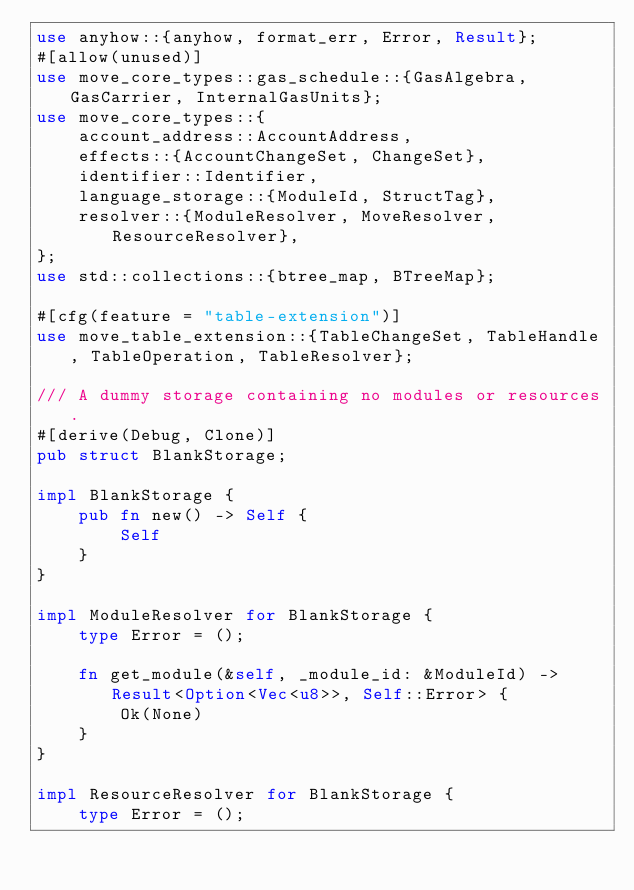Convert code to text. <code><loc_0><loc_0><loc_500><loc_500><_Rust_>use anyhow::{anyhow, format_err, Error, Result};
#[allow(unused)]
use move_core_types::gas_schedule::{GasAlgebra, GasCarrier, InternalGasUnits};
use move_core_types::{
    account_address::AccountAddress,
    effects::{AccountChangeSet, ChangeSet},
    identifier::Identifier,
    language_storage::{ModuleId, StructTag},
    resolver::{ModuleResolver, MoveResolver, ResourceResolver},
};
use std::collections::{btree_map, BTreeMap};

#[cfg(feature = "table-extension")]
use move_table_extension::{TableChangeSet, TableHandle, TableOperation, TableResolver};

/// A dummy storage containing no modules or resources.
#[derive(Debug, Clone)]
pub struct BlankStorage;

impl BlankStorage {
    pub fn new() -> Self {
        Self
    }
}

impl ModuleResolver for BlankStorage {
    type Error = ();

    fn get_module(&self, _module_id: &ModuleId) -> Result<Option<Vec<u8>>, Self::Error> {
        Ok(None)
    }
}

impl ResourceResolver for BlankStorage {
    type Error = ();
</code> 